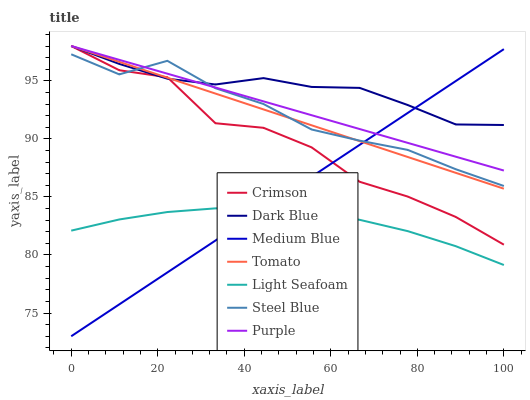Does Purple have the minimum area under the curve?
Answer yes or no. No. Does Purple have the maximum area under the curve?
Answer yes or no. No. Is Medium Blue the smoothest?
Answer yes or no. No. Is Medium Blue the roughest?
Answer yes or no. No. Does Purple have the lowest value?
Answer yes or no. No. Does Medium Blue have the highest value?
Answer yes or no. No. Is Light Seafoam less than Crimson?
Answer yes or no. Yes. Is Purple greater than Light Seafoam?
Answer yes or no. Yes. Does Light Seafoam intersect Crimson?
Answer yes or no. No. 